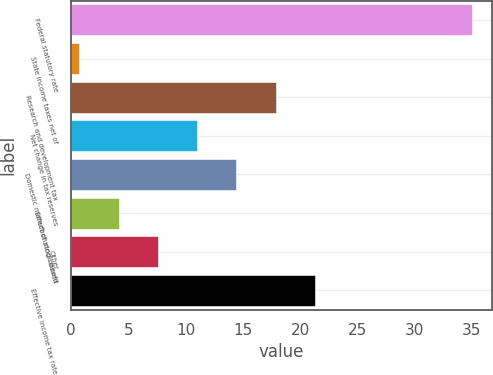<chart> <loc_0><loc_0><loc_500><loc_500><bar_chart><fcel>Federal statutory rate<fcel>State income taxes net of<fcel>Research and development tax<fcel>Net change in tax reserves<fcel>Domestic manufacturing benefit<fcel>Effect of stock-based<fcel>Other<fcel>Effective income tax rate<nl><fcel>35<fcel>0.7<fcel>17.85<fcel>10.99<fcel>14.42<fcel>4.13<fcel>7.56<fcel>21.28<nl></chart> 